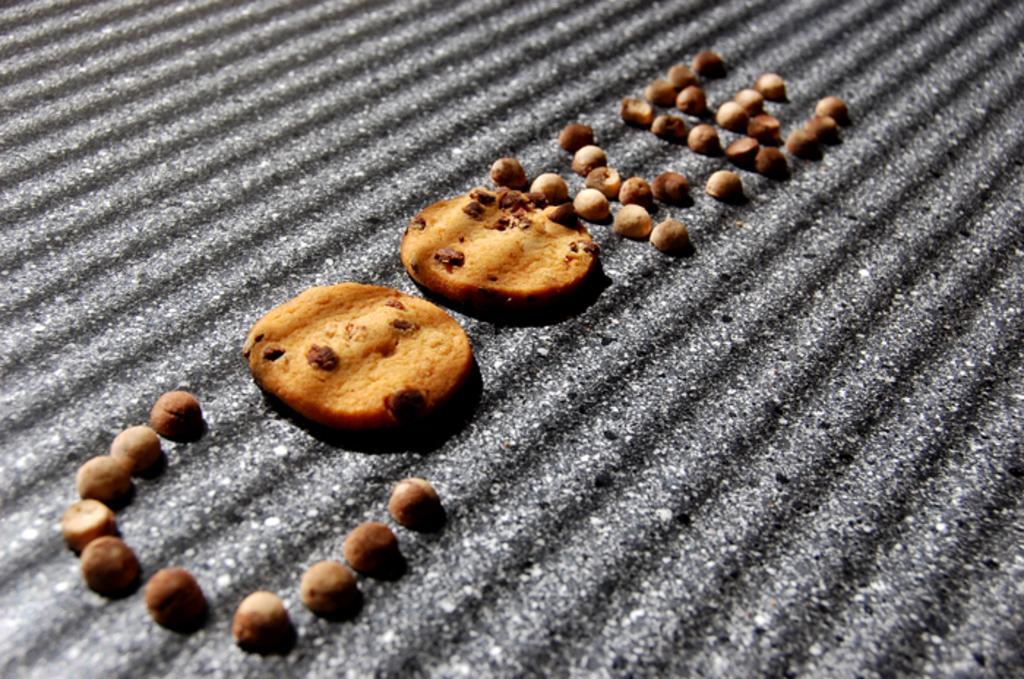Could you give a brief overview of what you see in this image? This picture contains cookies which are placed on the black color sheet. 